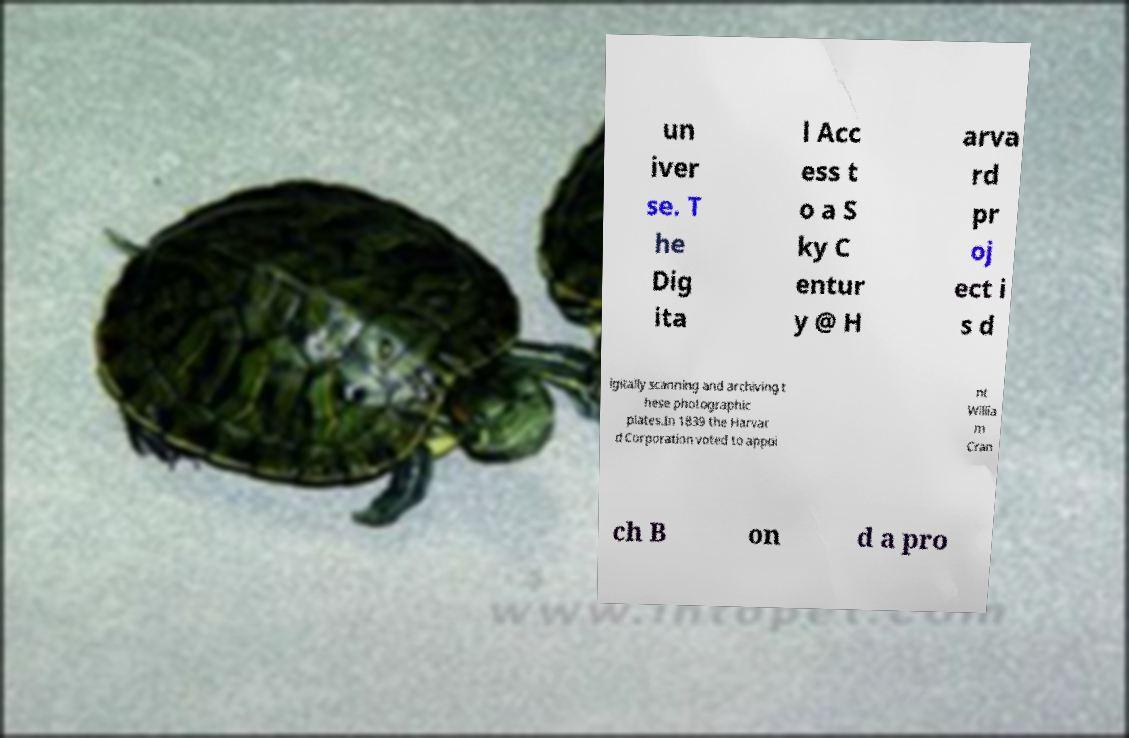What messages or text are displayed in this image? I need them in a readable, typed format. un iver se. T he Dig ita l Acc ess t o a S ky C entur y @ H arva rd pr oj ect i s d igitally scanning and archiving t hese photographic plates.In 1839 the Harvar d Corporation voted to appoi nt Willia m Cran ch B on d a pro 